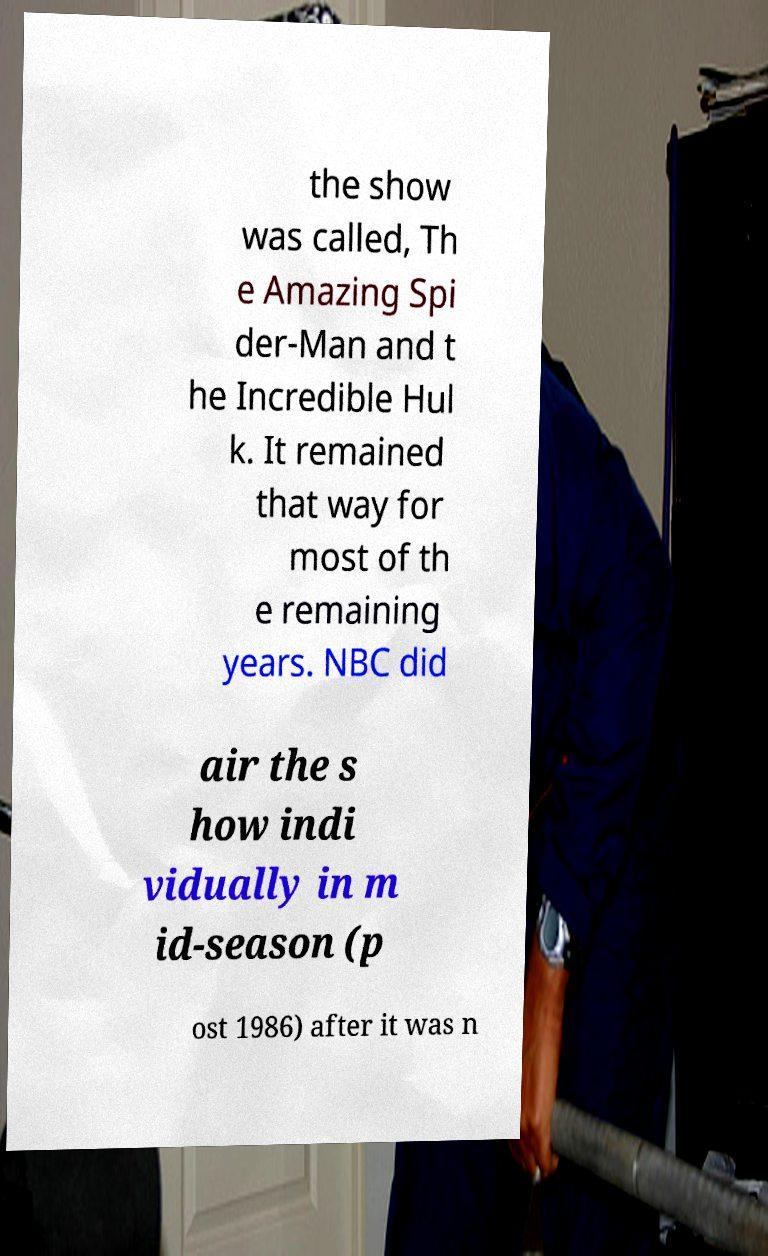Please identify and transcribe the text found in this image. the show was called, Th e Amazing Spi der-Man and t he Incredible Hul k. It remained that way for most of th e remaining years. NBC did air the s how indi vidually in m id-season (p ost 1986) after it was n 